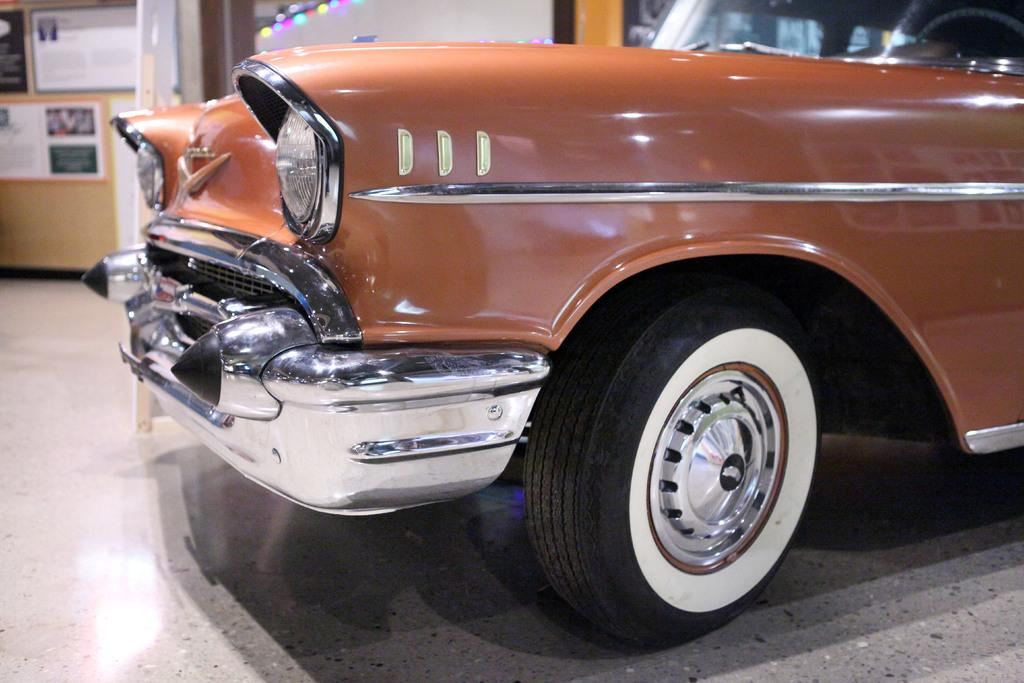What type of object is the main subject of the image? There is a vehicle in the image. What color is the vehicle? The vehicle is brown in color. What can be seen in the background of the image? There are boards visible in the background of the image. Where is the vehicle located? The vehicle is inside a building. How many times has the vehicle been folded in the image? The vehicle cannot be folded, so it has not been folded any times in the image. 